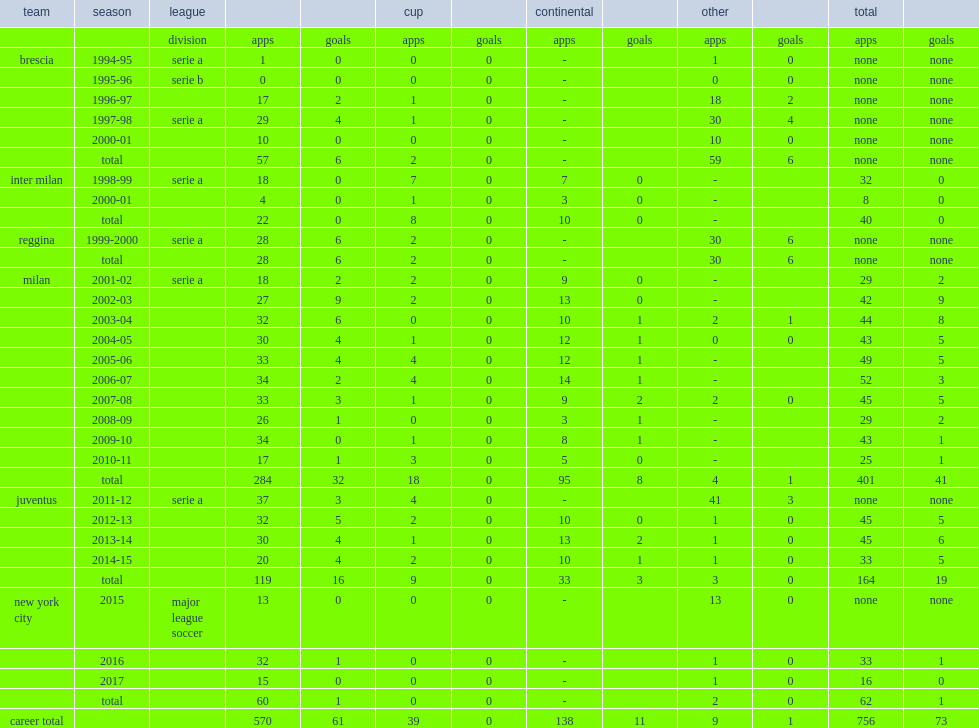Which team did pirlo play for in 2013-14? Juventus. 